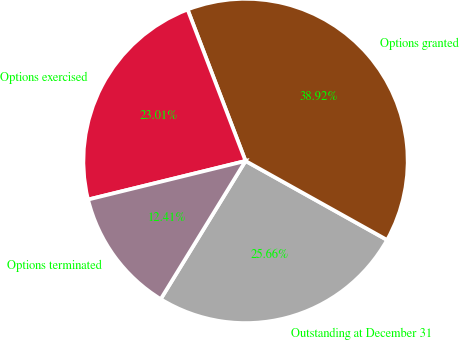Convert chart to OTSL. <chart><loc_0><loc_0><loc_500><loc_500><pie_chart><fcel>Outstanding at December 31<fcel>Options granted<fcel>Options exercised<fcel>Options terminated<nl><fcel>25.66%<fcel>38.92%<fcel>23.01%<fcel>12.41%<nl></chart> 